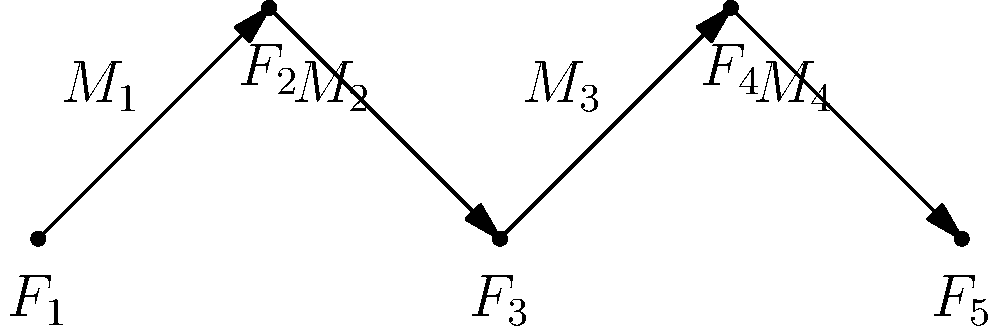In the graph above, each node represents a noble family ($F_1$ to $F_5$), and each edge represents a marriage ($M_1$ to $M_4$) between two families. What is the minimum number of marriages needed to connect the Bourbon family ($F_1$) to the Habsburg family ($F_5$)? To solve this problem, we need to analyze the graph and count the minimum number of edges (marriages) required to create a path from $F_1$ to $F_5$. Let's follow these steps:

1. Identify the starting and ending points:
   - Starting point: $F_1$ (Bourbon family)
   - Ending point: $F_5$ (Habsburg family)

2. Trace the path from $F_1$ to $F_5$:
   - $F_1$ to $F_2$: Marriage $M_1$
   - $F_2$ to $F_3$: Marriage $M_2$
   - $F_3$ to $F_4$: Marriage $M_3$
   - $F_4$ to $F_5$: Marriage $M_4$

3. Count the number of marriages in the path:
   - There are 4 marriages ($M_1$, $M_2$, $M_3$, and $M_4$) connecting $F_1$ to $F_5$

4. Verify that this is the minimum number:
   - The graph shows a linear path with no shortcuts or alternative routes
   - Removing any marriage would disconnect the path between $F_1$ and $F_5$

Therefore, the minimum number of marriages needed to connect the Bourbon family ($F_1$) to the Habsburg family ($F_5$) is 4.
Answer: 4 